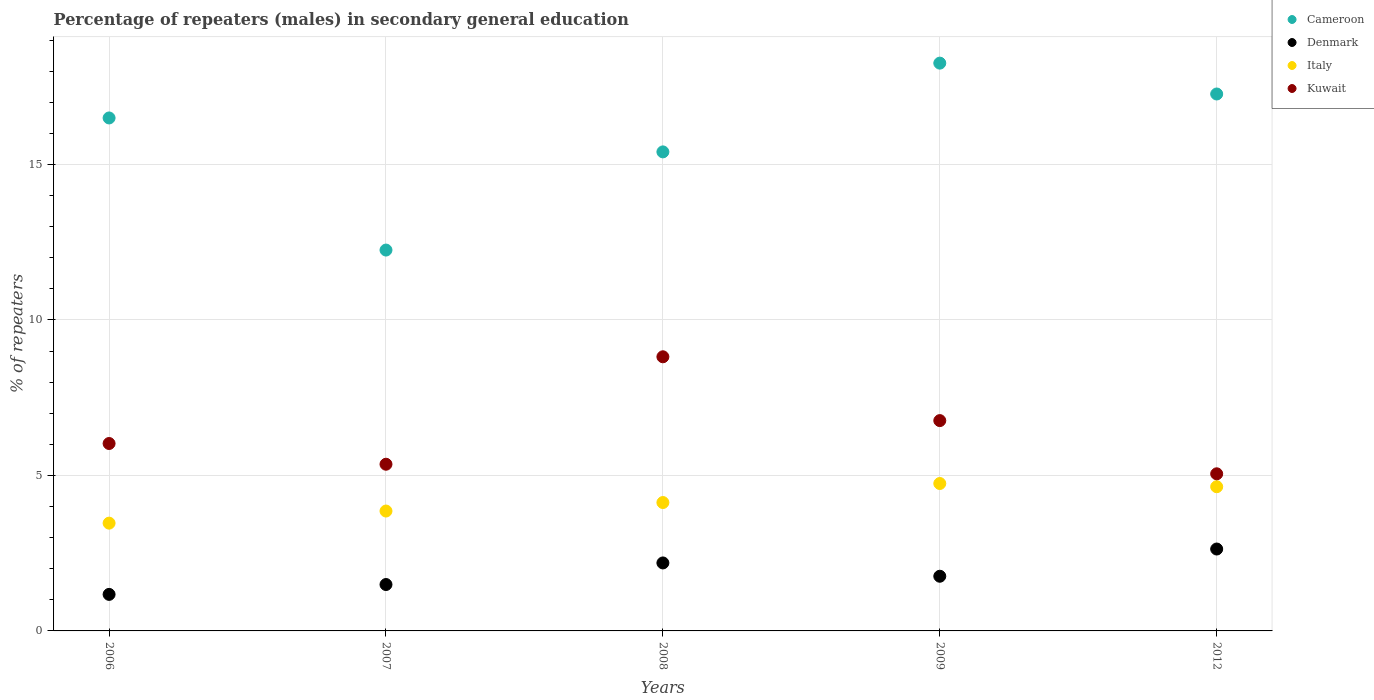Is the number of dotlines equal to the number of legend labels?
Your answer should be compact. Yes. What is the percentage of male repeaters in Denmark in 2009?
Ensure brevity in your answer.  1.76. Across all years, what is the maximum percentage of male repeaters in Denmark?
Offer a terse response. 2.63. Across all years, what is the minimum percentage of male repeaters in Kuwait?
Give a very brief answer. 5.05. What is the total percentage of male repeaters in Denmark in the graph?
Offer a very short reply. 9.25. What is the difference between the percentage of male repeaters in Cameroon in 2006 and that in 2007?
Provide a succinct answer. 4.25. What is the difference between the percentage of male repeaters in Cameroon in 2012 and the percentage of male repeaters in Kuwait in 2007?
Provide a succinct answer. 11.91. What is the average percentage of male repeaters in Denmark per year?
Keep it short and to the point. 1.85. In the year 2008, what is the difference between the percentage of male repeaters in Kuwait and percentage of male repeaters in Denmark?
Your response must be concise. 6.63. What is the ratio of the percentage of male repeaters in Kuwait in 2006 to that in 2009?
Offer a terse response. 0.89. Is the difference between the percentage of male repeaters in Kuwait in 2006 and 2008 greater than the difference between the percentage of male repeaters in Denmark in 2006 and 2008?
Provide a short and direct response. No. What is the difference between the highest and the second highest percentage of male repeaters in Italy?
Give a very brief answer. 0.1. What is the difference between the highest and the lowest percentage of male repeaters in Denmark?
Offer a terse response. 1.46. In how many years, is the percentage of male repeaters in Kuwait greater than the average percentage of male repeaters in Kuwait taken over all years?
Offer a very short reply. 2. Is the sum of the percentage of male repeaters in Kuwait in 2006 and 2009 greater than the maximum percentage of male repeaters in Cameroon across all years?
Offer a very short reply. No. Is it the case that in every year, the sum of the percentage of male repeaters in Denmark and percentage of male repeaters in Kuwait  is greater than the sum of percentage of male repeaters in Italy and percentage of male repeaters in Cameroon?
Make the answer very short. Yes. Is it the case that in every year, the sum of the percentage of male repeaters in Cameroon and percentage of male repeaters in Denmark  is greater than the percentage of male repeaters in Kuwait?
Give a very brief answer. Yes. Does the percentage of male repeaters in Cameroon monotonically increase over the years?
Make the answer very short. No. Is the percentage of male repeaters in Cameroon strictly greater than the percentage of male repeaters in Kuwait over the years?
Make the answer very short. Yes. Is the percentage of male repeaters in Italy strictly less than the percentage of male repeaters in Kuwait over the years?
Make the answer very short. Yes. How many dotlines are there?
Ensure brevity in your answer.  4. Are the values on the major ticks of Y-axis written in scientific E-notation?
Offer a terse response. No. Does the graph contain any zero values?
Ensure brevity in your answer.  No. Where does the legend appear in the graph?
Offer a very short reply. Top right. What is the title of the graph?
Give a very brief answer. Percentage of repeaters (males) in secondary general education. What is the label or title of the X-axis?
Offer a very short reply. Years. What is the label or title of the Y-axis?
Your answer should be compact. % of repeaters. What is the % of repeaters in Cameroon in 2006?
Offer a terse response. 16.5. What is the % of repeaters of Denmark in 2006?
Ensure brevity in your answer.  1.17. What is the % of repeaters of Italy in 2006?
Provide a short and direct response. 3.47. What is the % of repeaters of Kuwait in 2006?
Your response must be concise. 6.03. What is the % of repeaters of Cameroon in 2007?
Give a very brief answer. 12.25. What is the % of repeaters of Denmark in 2007?
Give a very brief answer. 1.49. What is the % of repeaters of Italy in 2007?
Your answer should be very brief. 3.86. What is the % of repeaters of Kuwait in 2007?
Your answer should be very brief. 5.36. What is the % of repeaters in Cameroon in 2008?
Make the answer very short. 15.41. What is the % of repeaters of Denmark in 2008?
Your answer should be very brief. 2.19. What is the % of repeaters of Italy in 2008?
Make the answer very short. 4.13. What is the % of repeaters of Kuwait in 2008?
Give a very brief answer. 8.82. What is the % of repeaters of Cameroon in 2009?
Make the answer very short. 18.26. What is the % of repeaters of Denmark in 2009?
Your response must be concise. 1.76. What is the % of repeaters in Italy in 2009?
Offer a terse response. 4.74. What is the % of repeaters in Kuwait in 2009?
Offer a very short reply. 6.76. What is the % of repeaters in Cameroon in 2012?
Offer a terse response. 17.27. What is the % of repeaters of Denmark in 2012?
Provide a short and direct response. 2.63. What is the % of repeaters of Italy in 2012?
Keep it short and to the point. 4.64. What is the % of repeaters of Kuwait in 2012?
Ensure brevity in your answer.  5.05. Across all years, what is the maximum % of repeaters in Cameroon?
Provide a succinct answer. 18.26. Across all years, what is the maximum % of repeaters in Denmark?
Give a very brief answer. 2.63. Across all years, what is the maximum % of repeaters in Italy?
Offer a very short reply. 4.74. Across all years, what is the maximum % of repeaters in Kuwait?
Give a very brief answer. 8.82. Across all years, what is the minimum % of repeaters of Cameroon?
Offer a terse response. 12.25. Across all years, what is the minimum % of repeaters in Denmark?
Keep it short and to the point. 1.17. Across all years, what is the minimum % of repeaters of Italy?
Offer a terse response. 3.47. Across all years, what is the minimum % of repeaters of Kuwait?
Provide a succinct answer. 5.05. What is the total % of repeaters in Cameroon in the graph?
Give a very brief answer. 79.68. What is the total % of repeaters in Denmark in the graph?
Give a very brief answer. 9.25. What is the total % of repeaters of Italy in the graph?
Keep it short and to the point. 20.83. What is the total % of repeaters of Kuwait in the graph?
Make the answer very short. 32.02. What is the difference between the % of repeaters of Cameroon in 2006 and that in 2007?
Keep it short and to the point. 4.25. What is the difference between the % of repeaters of Denmark in 2006 and that in 2007?
Provide a succinct answer. -0.32. What is the difference between the % of repeaters in Italy in 2006 and that in 2007?
Your answer should be very brief. -0.39. What is the difference between the % of repeaters of Kuwait in 2006 and that in 2007?
Make the answer very short. 0.67. What is the difference between the % of repeaters of Cameroon in 2006 and that in 2008?
Provide a short and direct response. 1.09. What is the difference between the % of repeaters of Denmark in 2006 and that in 2008?
Keep it short and to the point. -1.01. What is the difference between the % of repeaters of Italy in 2006 and that in 2008?
Ensure brevity in your answer.  -0.66. What is the difference between the % of repeaters of Kuwait in 2006 and that in 2008?
Your answer should be very brief. -2.79. What is the difference between the % of repeaters of Cameroon in 2006 and that in 2009?
Keep it short and to the point. -1.76. What is the difference between the % of repeaters in Denmark in 2006 and that in 2009?
Ensure brevity in your answer.  -0.58. What is the difference between the % of repeaters of Italy in 2006 and that in 2009?
Offer a very short reply. -1.27. What is the difference between the % of repeaters of Kuwait in 2006 and that in 2009?
Provide a succinct answer. -0.74. What is the difference between the % of repeaters of Cameroon in 2006 and that in 2012?
Offer a terse response. -0.77. What is the difference between the % of repeaters in Denmark in 2006 and that in 2012?
Make the answer very short. -1.46. What is the difference between the % of repeaters of Italy in 2006 and that in 2012?
Keep it short and to the point. -1.17. What is the difference between the % of repeaters in Kuwait in 2006 and that in 2012?
Keep it short and to the point. 0.97. What is the difference between the % of repeaters in Cameroon in 2007 and that in 2008?
Your answer should be very brief. -3.16. What is the difference between the % of repeaters in Denmark in 2007 and that in 2008?
Your response must be concise. -0.69. What is the difference between the % of repeaters in Italy in 2007 and that in 2008?
Provide a short and direct response. -0.27. What is the difference between the % of repeaters in Kuwait in 2007 and that in 2008?
Offer a very short reply. -3.46. What is the difference between the % of repeaters in Cameroon in 2007 and that in 2009?
Provide a short and direct response. -6.01. What is the difference between the % of repeaters in Denmark in 2007 and that in 2009?
Keep it short and to the point. -0.27. What is the difference between the % of repeaters in Italy in 2007 and that in 2009?
Your response must be concise. -0.89. What is the difference between the % of repeaters in Kuwait in 2007 and that in 2009?
Keep it short and to the point. -1.4. What is the difference between the % of repeaters in Cameroon in 2007 and that in 2012?
Make the answer very short. -5.02. What is the difference between the % of repeaters of Denmark in 2007 and that in 2012?
Your response must be concise. -1.14. What is the difference between the % of repeaters in Italy in 2007 and that in 2012?
Make the answer very short. -0.78. What is the difference between the % of repeaters of Kuwait in 2007 and that in 2012?
Ensure brevity in your answer.  0.31. What is the difference between the % of repeaters in Cameroon in 2008 and that in 2009?
Your answer should be compact. -2.85. What is the difference between the % of repeaters of Denmark in 2008 and that in 2009?
Keep it short and to the point. 0.43. What is the difference between the % of repeaters in Italy in 2008 and that in 2009?
Offer a very short reply. -0.61. What is the difference between the % of repeaters of Kuwait in 2008 and that in 2009?
Your answer should be compact. 2.05. What is the difference between the % of repeaters in Cameroon in 2008 and that in 2012?
Make the answer very short. -1.86. What is the difference between the % of repeaters of Denmark in 2008 and that in 2012?
Provide a succinct answer. -0.45. What is the difference between the % of repeaters in Italy in 2008 and that in 2012?
Offer a terse response. -0.51. What is the difference between the % of repeaters of Kuwait in 2008 and that in 2012?
Make the answer very short. 3.76. What is the difference between the % of repeaters of Denmark in 2009 and that in 2012?
Your response must be concise. -0.88. What is the difference between the % of repeaters of Italy in 2009 and that in 2012?
Make the answer very short. 0.1. What is the difference between the % of repeaters of Kuwait in 2009 and that in 2012?
Give a very brief answer. 1.71. What is the difference between the % of repeaters of Cameroon in 2006 and the % of repeaters of Denmark in 2007?
Provide a short and direct response. 15.01. What is the difference between the % of repeaters of Cameroon in 2006 and the % of repeaters of Italy in 2007?
Your answer should be compact. 12.64. What is the difference between the % of repeaters of Cameroon in 2006 and the % of repeaters of Kuwait in 2007?
Provide a succinct answer. 11.14. What is the difference between the % of repeaters in Denmark in 2006 and the % of repeaters in Italy in 2007?
Give a very brief answer. -2.68. What is the difference between the % of repeaters of Denmark in 2006 and the % of repeaters of Kuwait in 2007?
Give a very brief answer. -4.19. What is the difference between the % of repeaters of Italy in 2006 and the % of repeaters of Kuwait in 2007?
Give a very brief answer. -1.89. What is the difference between the % of repeaters in Cameroon in 2006 and the % of repeaters in Denmark in 2008?
Your response must be concise. 14.31. What is the difference between the % of repeaters of Cameroon in 2006 and the % of repeaters of Italy in 2008?
Provide a short and direct response. 12.37. What is the difference between the % of repeaters of Cameroon in 2006 and the % of repeaters of Kuwait in 2008?
Your answer should be very brief. 7.68. What is the difference between the % of repeaters of Denmark in 2006 and the % of repeaters of Italy in 2008?
Offer a very short reply. -2.95. What is the difference between the % of repeaters of Denmark in 2006 and the % of repeaters of Kuwait in 2008?
Your response must be concise. -7.64. What is the difference between the % of repeaters in Italy in 2006 and the % of repeaters in Kuwait in 2008?
Your answer should be compact. -5.35. What is the difference between the % of repeaters of Cameroon in 2006 and the % of repeaters of Denmark in 2009?
Your answer should be very brief. 14.74. What is the difference between the % of repeaters in Cameroon in 2006 and the % of repeaters in Italy in 2009?
Provide a short and direct response. 11.76. What is the difference between the % of repeaters in Cameroon in 2006 and the % of repeaters in Kuwait in 2009?
Keep it short and to the point. 9.73. What is the difference between the % of repeaters in Denmark in 2006 and the % of repeaters in Italy in 2009?
Give a very brief answer. -3.57. What is the difference between the % of repeaters of Denmark in 2006 and the % of repeaters of Kuwait in 2009?
Provide a succinct answer. -5.59. What is the difference between the % of repeaters of Italy in 2006 and the % of repeaters of Kuwait in 2009?
Your response must be concise. -3.3. What is the difference between the % of repeaters of Cameroon in 2006 and the % of repeaters of Denmark in 2012?
Provide a short and direct response. 13.86. What is the difference between the % of repeaters of Cameroon in 2006 and the % of repeaters of Italy in 2012?
Provide a succinct answer. 11.86. What is the difference between the % of repeaters in Cameroon in 2006 and the % of repeaters in Kuwait in 2012?
Make the answer very short. 11.44. What is the difference between the % of repeaters of Denmark in 2006 and the % of repeaters of Italy in 2012?
Offer a terse response. -3.46. What is the difference between the % of repeaters of Denmark in 2006 and the % of repeaters of Kuwait in 2012?
Keep it short and to the point. -3.88. What is the difference between the % of repeaters of Italy in 2006 and the % of repeaters of Kuwait in 2012?
Keep it short and to the point. -1.59. What is the difference between the % of repeaters in Cameroon in 2007 and the % of repeaters in Denmark in 2008?
Make the answer very short. 10.06. What is the difference between the % of repeaters in Cameroon in 2007 and the % of repeaters in Italy in 2008?
Provide a short and direct response. 8.12. What is the difference between the % of repeaters of Cameroon in 2007 and the % of repeaters of Kuwait in 2008?
Provide a succinct answer. 3.43. What is the difference between the % of repeaters in Denmark in 2007 and the % of repeaters in Italy in 2008?
Make the answer very short. -2.64. What is the difference between the % of repeaters of Denmark in 2007 and the % of repeaters of Kuwait in 2008?
Ensure brevity in your answer.  -7.32. What is the difference between the % of repeaters in Italy in 2007 and the % of repeaters in Kuwait in 2008?
Give a very brief answer. -4.96. What is the difference between the % of repeaters in Cameroon in 2007 and the % of repeaters in Denmark in 2009?
Offer a terse response. 10.49. What is the difference between the % of repeaters of Cameroon in 2007 and the % of repeaters of Italy in 2009?
Your answer should be compact. 7.51. What is the difference between the % of repeaters of Cameroon in 2007 and the % of repeaters of Kuwait in 2009?
Provide a succinct answer. 5.48. What is the difference between the % of repeaters in Denmark in 2007 and the % of repeaters in Italy in 2009?
Your answer should be compact. -3.25. What is the difference between the % of repeaters of Denmark in 2007 and the % of repeaters of Kuwait in 2009?
Ensure brevity in your answer.  -5.27. What is the difference between the % of repeaters of Italy in 2007 and the % of repeaters of Kuwait in 2009?
Offer a terse response. -2.91. What is the difference between the % of repeaters of Cameroon in 2007 and the % of repeaters of Denmark in 2012?
Your answer should be compact. 9.61. What is the difference between the % of repeaters in Cameroon in 2007 and the % of repeaters in Italy in 2012?
Provide a short and direct response. 7.61. What is the difference between the % of repeaters of Cameroon in 2007 and the % of repeaters of Kuwait in 2012?
Your answer should be very brief. 7.2. What is the difference between the % of repeaters in Denmark in 2007 and the % of repeaters in Italy in 2012?
Offer a very short reply. -3.15. What is the difference between the % of repeaters in Denmark in 2007 and the % of repeaters in Kuwait in 2012?
Your response must be concise. -3.56. What is the difference between the % of repeaters of Italy in 2007 and the % of repeaters of Kuwait in 2012?
Your answer should be compact. -1.2. What is the difference between the % of repeaters of Cameroon in 2008 and the % of repeaters of Denmark in 2009?
Ensure brevity in your answer.  13.65. What is the difference between the % of repeaters of Cameroon in 2008 and the % of repeaters of Italy in 2009?
Your response must be concise. 10.66. What is the difference between the % of repeaters in Cameroon in 2008 and the % of repeaters in Kuwait in 2009?
Your answer should be compact. 8.64. What is the difference between the % of repeaters of Denmark in 2008 and the % of repeaters of Italy in 2009?
Provide a short and direct response. -2.55. What is the difference between the % of repeaters of Denmark in 2008 and the % of repeaters of Kuwait in 2009?
Your answer should be very brief. -4.58. What is the difference between the % of repeaters in Italy in 2008 and the % of repeaters in Kuwait in 2009?
Give a very brief answer. -2.64. What is the difference between the % of repeaters of Cameroon in 2008 and the % of repeaters of Denmark in 2012?
Keep it short and to the point. 12.77. What is the difference between the % of repeaters of Cameroon in 2008 and the % of repeaters of Italy in 2012?
Provide a succinct answer. 10.77. What is the difference between the % of repeaters of Cameroon in 2008 and the % of repeaters of Kuwait in 2012?
Your answer should be very brief. 10.35. What is the difference between the % of repeaters of Denmark in 2008 and the % of repeaters of Italy in 2012?
Keep it short and to the point. -2.45. What is the difference between the % of repeaters in Denmark in 2008 and the % of repeaters in Kuwait in 2012?
Your answer should be very brief. -2.87. What is the difference between the % of repeaters in Italy in 2008 and the % of repeaters in Kuwait in 2012?
Offer a very short reply. -0.92. What is the difference between the % of repeaters in Cameroon in 2009 and the % of repeaters in Denmark in 2012?
Ensure brevity in your answer.  15.63. What is the difference between the % of repeaters in Cameroon in 2009 and the % of repeaters in Italy in 2012?
Keep it short and to the point. 13.62. What is the difference between the % of repeaters in Cameroon in 2009 and the % of repeaters in Kuwait in 2012?
Keep it short and to the point. 13.21. What is the difference between the % of repeaters of Denmark in 2009 and the % of repeaters of Italy in 2012?
Your answer should be very brief. -2.88. What is the difference between the % of repeaters of Denmark in 2009 and the % of repeaters of Kuwait in 2012?
Keep it short and to the point. -3.29. What is the difference between the % of repeaters of Italy in 2009 and the % of repeaters of Kuwait in 2012?
Make the answer very short. -0.31. What is the average % of repeaters in Cameroon per year?
Your response must be concise. 15.94. What is the average % of repeaters of Denmark per year?
Your response must be concise. 1.85. What is the average % of repeaters of Italy per year?
Offer a very short reply. 4.17. What is the average % of repeaters in Kuwait per year?
Keep it short and to the point. 6.4. In the year 2006, what is the difference between the % of repeaters of Cameroon and % of repeaters of Denmark?
Your response must be concise. 15.32. In the year 2006, what is the difference between the % of repeaters of Cameroon and % of repeaters of Italy?
Offer a very short reply. 13.03. In the year 2006, what is the difference between the % of repeaters of Cameroon and % of repeaters of Kuwait?
Your answer should be compact. 10.47. In the year 2006, what is the difference between the % of repeaters in Denmark and % of repeaters in Italy?
Your answer should be compact. -2.29. In the year 2006, what is the difference between the % of repeaters in Denmark and % of repeaters in Kuwait?
Provide a succinct answer. -4.85. In the year 2006, what is the difference between the % of repeaters of Italy and % of repeaters of Kuwait?
Your response must be concise. -2.56. In the year 2007, what is the difference between the % of repeaters in Cameroon and % of repeaters in Denmark?
Your answer should be very brief. 10.76. In the year 2007, what is the difference between the % of repeaters of Cameroon and % of repeaters of Italy?
Your answer should be compact. 8.39. In the year 2007, what is the difference between the % of repeaters in Cameroon and % of repeaters in Kuwait?
Keep it short and to the point. 6.89. In the year 2007, what is the difference between the % of repeaters in Denmark and % of repeaters in Italy?
Your answer should be compact. -2.36. In the year 2007, what is the difference between the % of repeaters of Denmark and % of repeaters of Kuwait?
Your response must be concise. -3.87. In the year 2007, what is the difference between the % of repeaters of Italy and % of repeaters of Kuwait?
Ensure brevity in your answer.  -1.51. In the year 2008, what is the difference between the % of repeaters of Cameroon and % of repeaters of Denmark?
Ensure brevity in your answer.  13.22. In the year 2008, what is the difference between the % of repeaters in Cameroon and % of repeaters in Italy?
Your response must be concise. 11.28. In the year 2008, what is the difference between the % of repeaters of Cameroon and % of repeaters of Kuwait?
Offer a very short reply. 6.59. In the year 2008, what is the difference between the % of repeaters of Denmark and % of repeaters of Italy?
Offer a terse response. -1.94. In the year 2008, what is the difference between the % of repeaters of Denmark and % of repeaters of Kuwait?
Ensure brevity in your answer.  -6.63. In the year 2008, what is the difference between the % of repeaters in Italy and % of repeaters in Kuwait?
Make the answer very short. -4.69. In the year 2009, what is the difference between the % of repeaters in Cameroon and % of repeaters in Denmark?
Provide a short and direct response. 16.5. In the year 2009, what is the difference between the % of repeaters in Cameroon and % of repeaters in Italy?
Your response must be concise. 13.52. In the year 2009, what is the difference between the % of repeaters of Cameroon and % of repeaters of Kuwait?
Your answer should be very brief. 11.5. In the year 2009, what is the difference between the % of repeaters in Denmark and % of repeaters in Italy?
Your answer should be very brief. -2.98. In the year 2009, what is the difference between the % of repeaters in Denmark and % of repeaters in Kuwait?
Provide a short and direct response. -5.01. In the year 2009, what is the difference between the % of repeaters of Italy and % of repeaters of Kuwait?
Your response must be concise. -2.02. In the year 2012, what is the difference between the % of repeaters in Cameroon and % of repeaters in Denmark?
Your response must be concise. 14.63. In the year 2012, what is the difference between the % of repeaters of Cameroon and % of repeaters of Italy?
Your response must be concise. 12.63. In the year 2012, what is the difference between the % of repeaters in Cameroon and % of repeaters in Kuwait?
Provide a short and direct response. 12.22. In the year 2012, what is the difference between the % of repeaters of Denmark and % of repeaters of Italy?
Provide a short and direct response. -2. In the year 2012, what is the difference between the % of repeaters of Denmark and % of repeaters of Kuwait?
Your response must be concise. -2.42. In the year 2012, what is the difference between the % of repeaters of Italy and % of repeaters of Kuwait?
Your answer should be very brief. -0.42. What is the ratio of the % of repeaters in Cameroon in 2006 to that in 2007?
Keep it short and to the point. 1.35. What is the ratio of the % of repeaters in Denmark in 2006 to that in 2007?
Ensure brevity in your answer.  0.79. What is the ratio of the % of repeaters in Italy in 2006 to that in 2007?
Your answer should be compact. 0.9. What is the ratio of the % of repeaters in Kuwait in 2006 to that in 2007?
Your answer should be very brief. 1.12. What is the ratio of the % of repeaters of Cameroon in 2006 to that in 2008?
Ensure brevity in your answer.  1.07. What is the ratio of the % of repeaters in Denmark in 2006 to that in 2008?
Your response must be concise. 0.54. What is the ratio of the % of repeaters in Italy in 2006 to that in 2008?
Offer a terse response. 0.84. What is the ratio of the % of repeaters of Kuwait in 2006 to that in 2008?
Keep it short and to the point. 0.68. What is the ratio of the % of repeaters in Cameroon in 2006 to that in 2009?
Your answer should be compact. 0.9. What is the ratio of the % of repeaters in Denmark in 2006 to that in 2009?
Ensure brevity in your answer.  0.67. What is the ratio of the % of repeaters in Italy in 2006 to that in 2009?
Provide a short and direct response. 0.73. What is the ratio of the % of repeaters in Kuwait in 2006 to that in 2009?
Give a very brief answer. 0.89. What is the ratio of the % of repeaters of Cameroon in 2006 to that in 2012?
Provide a short and direct response. 0.96. What is the ratio of the % of repeaters of Denmark in 2006 to that in 2012?
Provide a short and direct response. 0.45. What is the ratio of the % of repeaters of Italy in 2006 to that in 2012?
Ensure brevity in your answer.  0.75. What is the ratio of the % of repeaters of Kuwait in 2006 to that in 2012?
Give a very brief answer. 1.19. What is the ratio of the % of repeaters in Cameroon in 2007 to that in 2008?
Your answer should be compact. 0.8. What is the ratio of the % of repeaters of Denmark in 2007 to that in 2008?
Make the answer very short. 0.68. What is the ratio of the % of repeaters in Italy in 2007 to that in 2008?
Keep it short and to the point. 0.93. What is the ratio of the % of repeaters of Kuwait in 2007 to that in 2008?
Your answer should be very brief. 0.61. What is the ratio of the % of repeaters in Cameroon in 2007 to that in 2009?
Provide a short and direct response. 0.67. What is the ratio of the % of repeaters of Denmark in 2007 to that in 2009?
Your answer should be very brief. 0.85. What is the ratio of the % of repeaters of Italy in 2007 to that in 2009?
Your answer should be compact. 0.81. What is the ratio of the % of repeaters of Kuwait in 2007 to that in 2009?
Your answer should be compact. 0.79. What is the ratio of the % of repeaters in Cameroon in 2007 to that in 2012?
Offer a very short reply. 0.71. What is the ratio of the % of repeaters in Denmark in 2007 to that in 2012?
Offer a terse response. 0.57. What is the ratio of the % of repeaters in Italy in 2007 to that in 2012?
Ensure brevity in your answer.  0.83. What is the ratio of the % of repeaters of Kuwait in 2007 to that in 2012?
Your answer should be compact. 1.06. What is the ratio of the % of repeaters of Cameroon in 2008 to that in 2009?
Provide a succinct answer. 0.84. What is the ratio of the % of repeaters in Denmark in 2008 to that in 2009?
Provide a short and direct response. 1.24. What is the ratio of the % of repeaters of Italy in 2008 to that in 2009?
Offer a very short reply. 0.87. What is the ratio of the % of repeaters of Kuwait in 2008 to that in 2009?
Ensure brevity in your answer.  1.3. What is the ratio of the % of repeaters in Cameroon in 2008 to that in 2012?
Your answer should be compact. 0.89. What is the ratio of the % of repeaters of Denmark in 2008 to that in 2012?
Offer a terse response. 0.83. What is the ratio of the % of repeaters of Italy in 2008 to that in 2012?
Give a very brief answer. 0.89. What is the ratio of the % of repeaters of Kuwait in 2008 to that in 2012?
Provide a short and direct response. 1.74. What is the ratio of the % of repeaters in Cameroon in 2009 to that in 2012?
Make the answer very short. 1.06. What is the ratio of the % of repeaters in Denmark in 2009 to that in 2012?
Offer a terse response. 0.67. What is the ratio of the % of repeaters of Italy in 2009 to that in 2012?
Offer a very short reply. 1.02. What is the ratio of the % of repeaters of Kuwait in 2009 to that in 2012?
Make the answer very short. 1.34. What is the difference between the highest and the second highest % of repeaters in Cameroon?
Make the answer very short. 0.99. What is the difference between the highest and the second highest % of repeaters in Denmark?
Give a very brief answer. 0.45. What is the difference between the highest and the second highest % of repeaters in Italy?
Keep it short and to the point. 0.1. What is the difference between the highest and the second highest % of repeaters of Kuwait?
Your response must be concise. 2.05. What is the difference between the highest and the lowest % of repeaters in Cameroon?
Offer a terse response. 6.01. What is the difference between the highest and the lowest % of repeaters in Denmark?
Keep it short and to the point. 1.46. What is the difference between the highest and the lowest % of repeaters of Italy?
Give a very brief answer. 1.27. What is the difference between the highest and the lowest % of repeaters in Kuwait?
Your answer should be very brief. 3.76. 